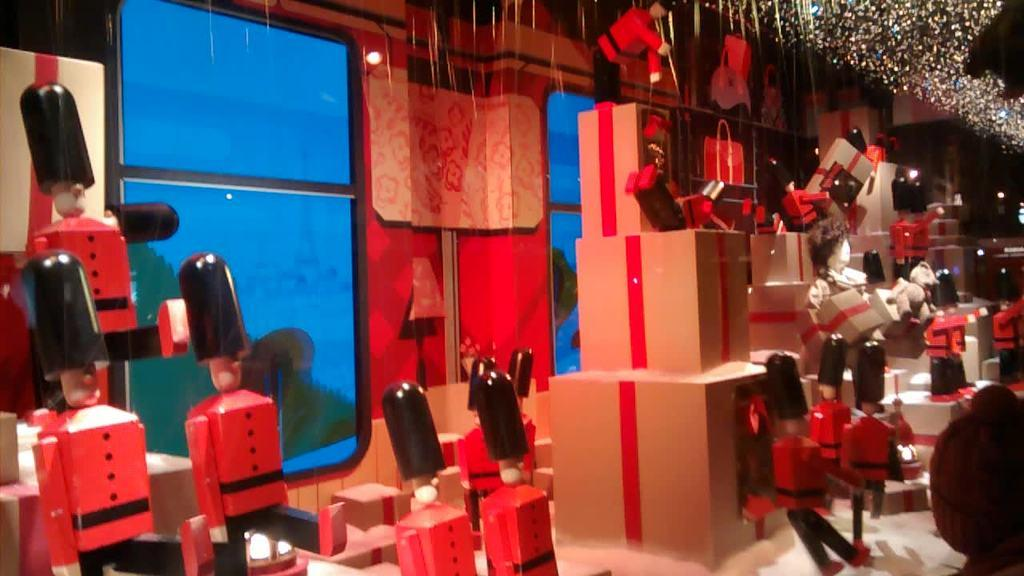What type of objects can be seen in the image? There are toys in the image. What colors are the toys? The toys are in black and red colors. What other items are present in the image besides the toys? There are cardboard boxes in the image. What can be seen in the background of the image? The background of the image includes a red wall and glass windows. What type of popcorn is being served in the image? There is no popcorn present in the image; it features toys, cardboard boxes, and a red wall with glass windows in the background. Can you see a screw holding the toys together in the image? There is no screw visible in the image; it only shows toys, cardboard boxes, and the background. 